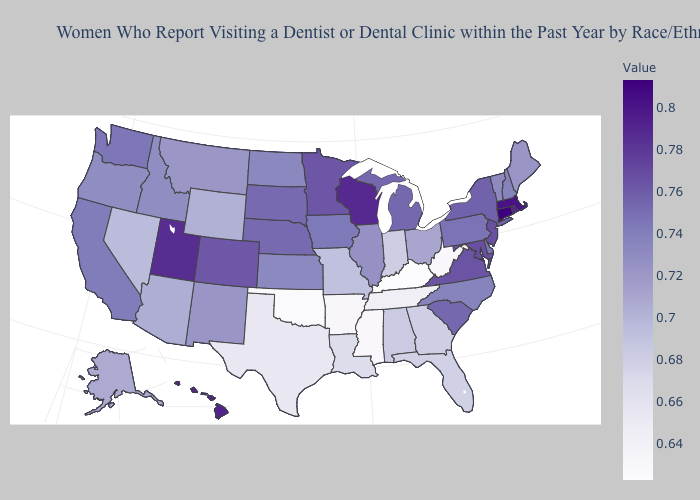Does the map have missing data?
Short answer required. No. Does New Jersey have the highest value in the USA?
Give a very brief answer. No. Among the states that border Nebraska , does Iowa have the lowest value?
Short answer required. No. Which states hav the highest value in the West?
Concise answer only. Hawaii. Does Idaho have the lowest value in the West?
Answer briefly. No. Which states have the lowest value in the USA?
Give a very brief answer. Kentucky. Which states have the highest value in the USA?
Write a very short answer. Connecticut. 